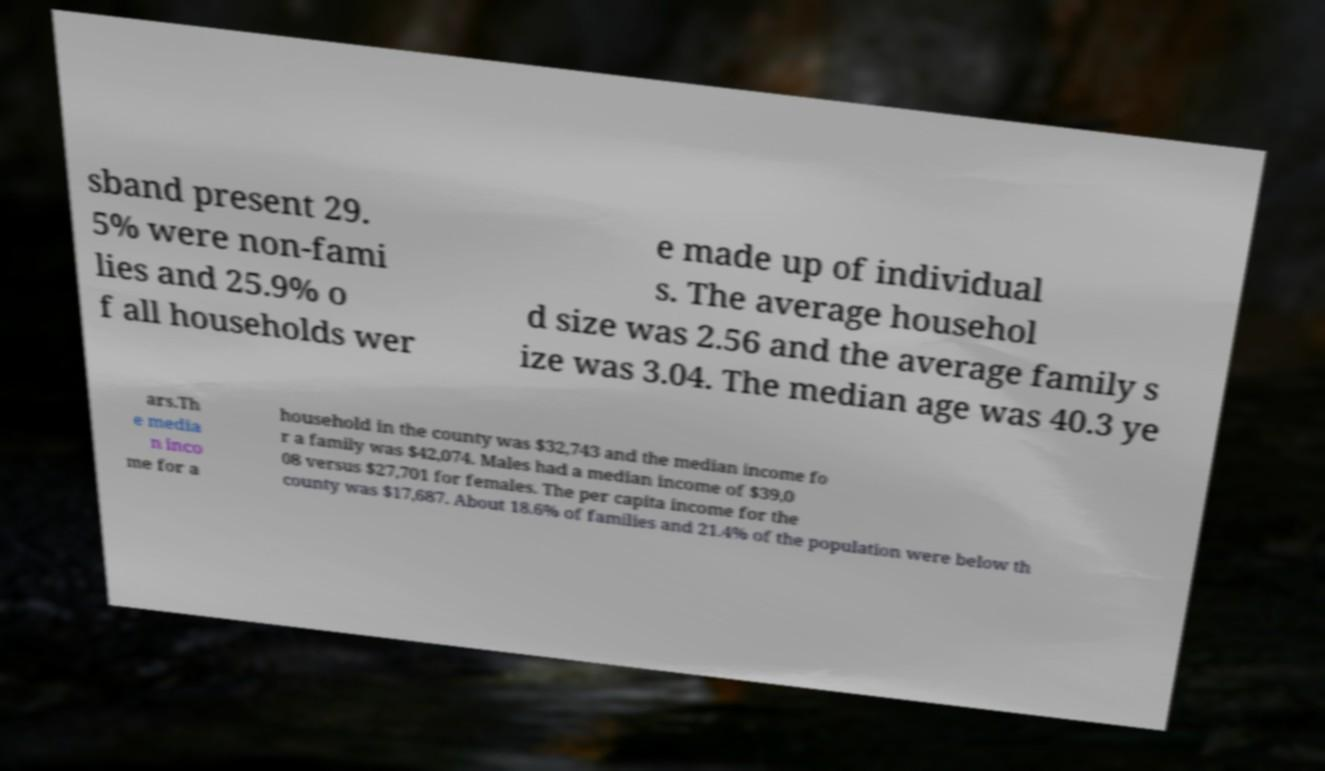Please read and relay the text visible in this image. What does it say? sband present 29. 5% were non-fami lies and 25.9% o f all households wer e made up of individual s. The average househol d size was 2.56 and the average family s ize was 3.04. The median age was 40.3 ye ars.Th e media n inco me for a household in the county was $32,743 and the median income fo r a family was $42,074. Males had a median income of $39,0 08 versus $27,701 for females. The per capita income for the county was $17,687. About 18.6% of families and 21.4% of the population were below th 